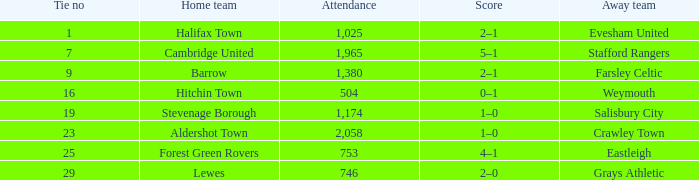What is the highest attendance for games with stevenage borough at home? 1174.0. 